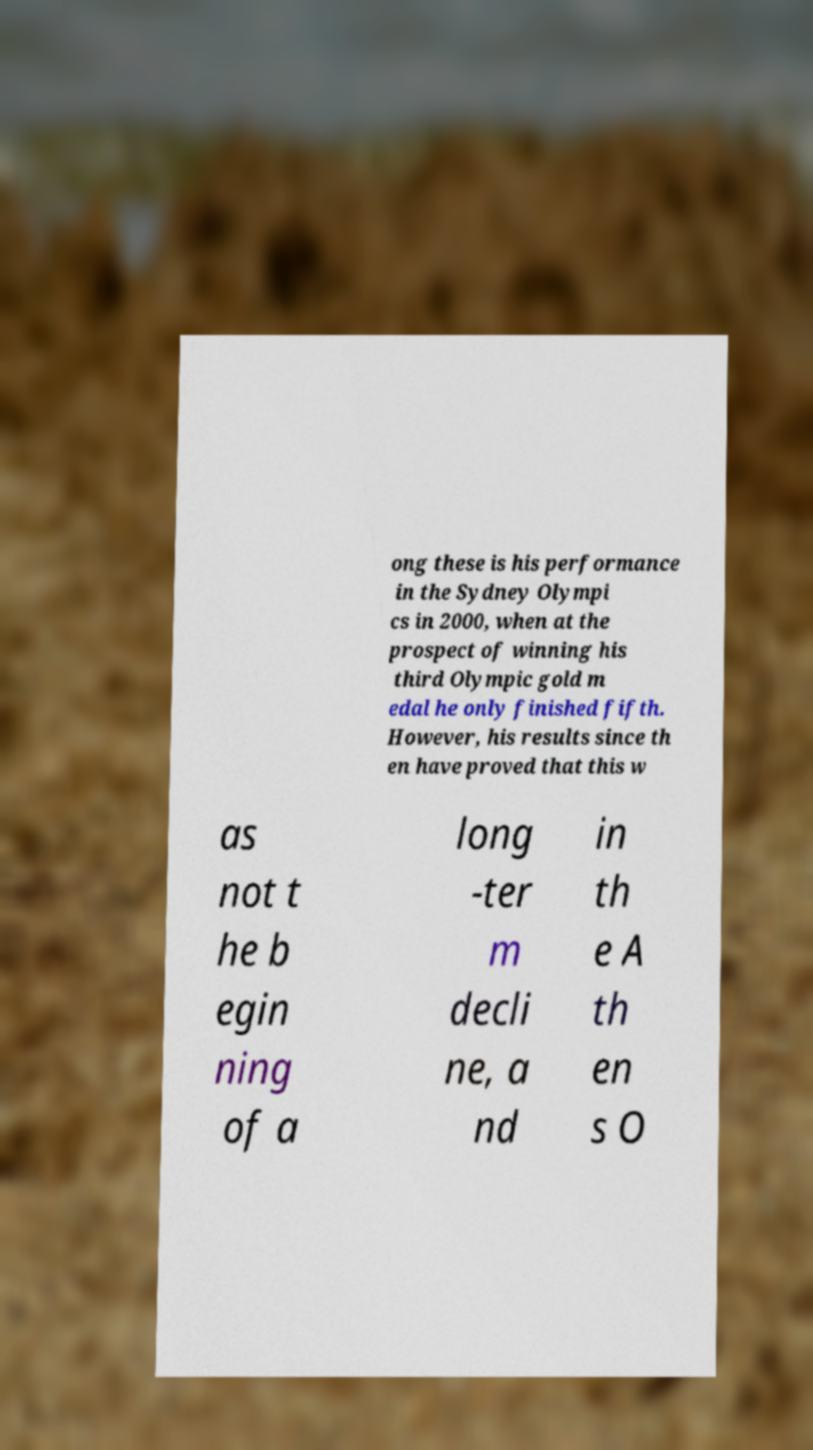There's text embedded in this image that I need extracted. Can you transcribe it verbatim? ong these is his performance in the Sydney Olympi cs in 2000, when at the prospect of winning his third Olympic gold m edal he only finished fifth. However, his results since th en have proved that this w as not t he b egin ning of a long -ter m decli ne, a nd in th e A th en s O 